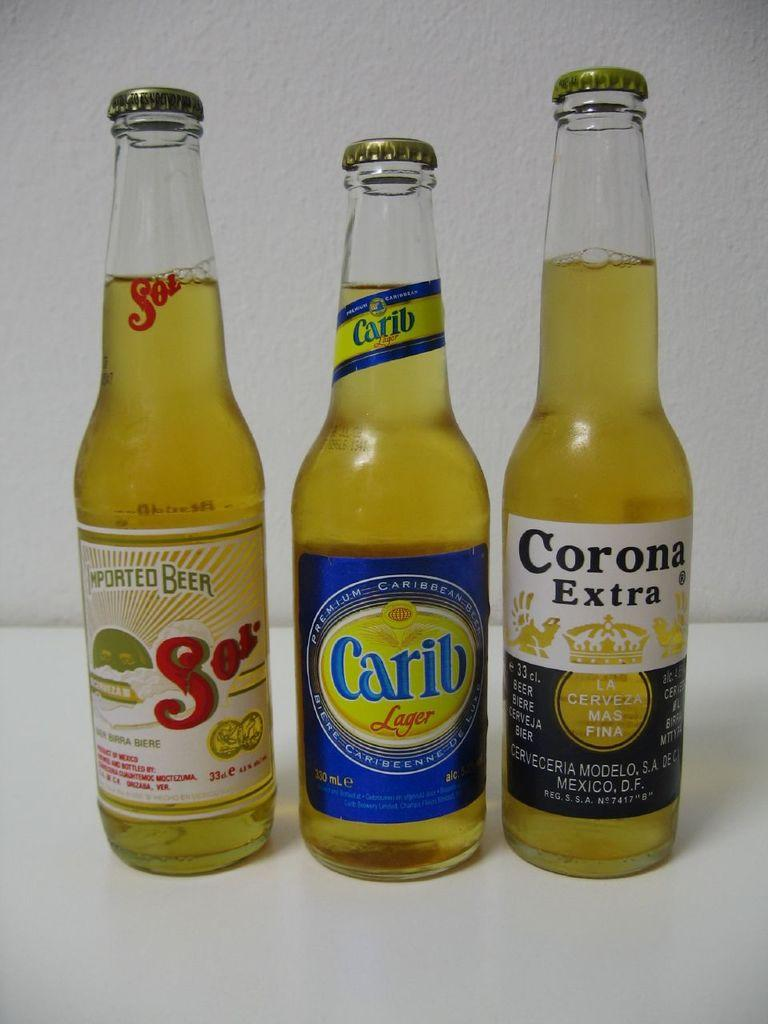<image>
Describe the image concisely. Three beer bottles Sol, Carib and Corona Extra. 